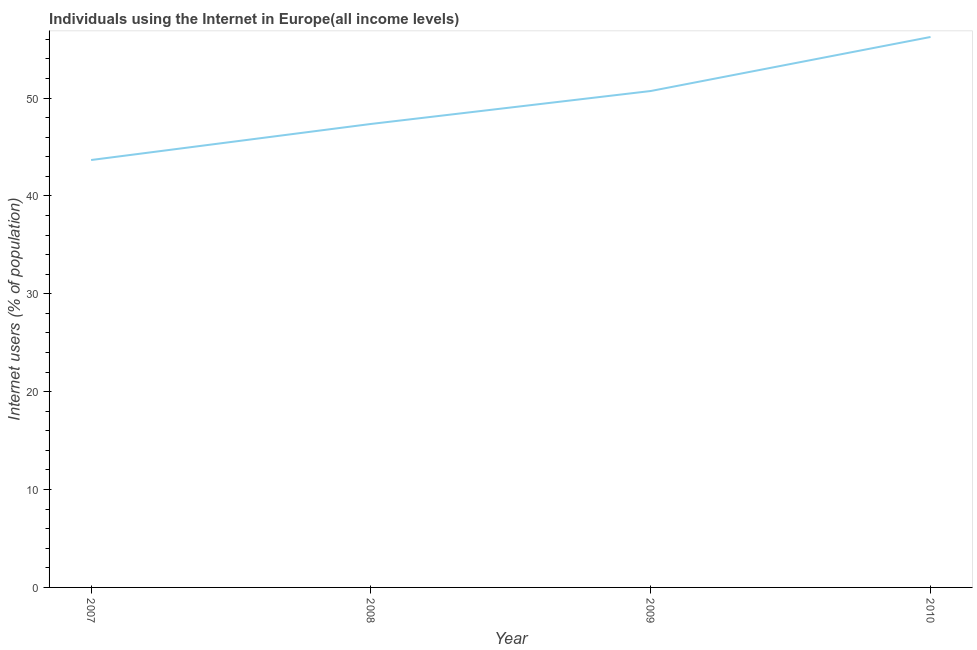What is the number of internet users in 2008?
Your response must be concise. 47.36. Across all years, what is the maximum number of internet users?
Your answer should be very brief. 56.25. Across all years, what is the minimum number of internet users?
Your response must be concise. 43.67. What is the sum of the number of internet users?
Keep it short and to the point. 198. What is the difference between the number of internet users in 2007 and 2008?
Your answer should be very brief. -3.68. What is the average number of internet users per year?
Offer a terse response. 49.5. What is the median number of internet users?
Keep it short and to the point. 49.04. In how many years, is the number of internet users greater than 26 %?
Ensure brevity in your answer.  4. What is the ratio of the number of internet users in 2007 to that in 2008?
Your response must be concise. 0.92. Is the number of internet users in 2007 less than that in 2009?
Your answer should be compact. Yes. Is the difference between the number of internet users in 2007 and 2008 greater than the difference between any two years?
Your answer should be very brief. No. What is the difference between the highest and the second highest number of internet users?
Your answer should be compact. 5.52. Is the sum of the number of internet users in 2008 and 2010 greater than the maximum number of internet users across all years?
Provide a succinct answer. Yes. What is the difference between the highest and the lowest number of internet users?
Offer a terse response. 12.57. How many lines are there?
Provide a succinct answer. 1. What is the difference between two consecutive major ticks on the Y-axis?
Provide a short and direct response. 10. Are the values on the major ticks of Y-axis written in scientific E-notation?
Your response must be concise. No. Does the graph contain any zero values?
Ensure brevity in your answer.  No. What is the title of the graph?
Provide a short and direct response. Individuals using the Internet in Europe(all income levels). What is the label or title of the X-axis?
Provide a short and direct response. Year. What is the label or title of the Y-axis?
Give a very brief answer. Internet users (% of population). What is the Internet users (% of population) of 2007?
Offer a very short reply. 43.67. What is the Internet users (% of population) of 2008?
Provide a short and direct response. 47.36. What is the Internet users (% of population) in 2009?
Offer a very short reply. 50.72. What is the Internet users (% of population) in 2010?
Your answer should be compact. 56.25. What is the difference between the Internet users (% of population) in 2007 and 2008?
Make the answer very short. -3.68. What is the difference between the Internet users (% of population) in 2007 and 2009?
Provide a short and direct response. -7.05. What is the difference between the Internet users (% of population) in 2007 and 2010?
Provide a succinct answer. -12.57. What is the difference between the Internet users (% of population) in 2008 and 2009?
Provide a succinct answer. -3.37. What is the difference between the Internet users (% of population) in 2008 and 2010?
Your answer should be compact. -8.89. What is the difference between the Internet users (% of population) in 2009 and 2010?
Your answer should be compact. -5.52. What is the ratio of the Internet users (% of population) in 2007 to that in 2008?
Provide a succinct answer. 0.92. What is the ratio of the Internet users (% of population) in 2007 to that in 2009?
Offer a very short reply. 0.86. What is the ratio of the Internet users (% of population) in 2007 to that in 2010?
Offer a very short reply. 0.78. What is the ratio of the Internet users (% of population) in 2008 to that in 2009?
Keep it short and to the point. 0.93. What is the ratio of the Internet users (% of population) in 2008 to that in 2010?
Your answer should be compact. 0.84. What is the ratio of the Internet users (% of population) in 2009 to that in 2010?
Give a very brief answer. 0.9. 